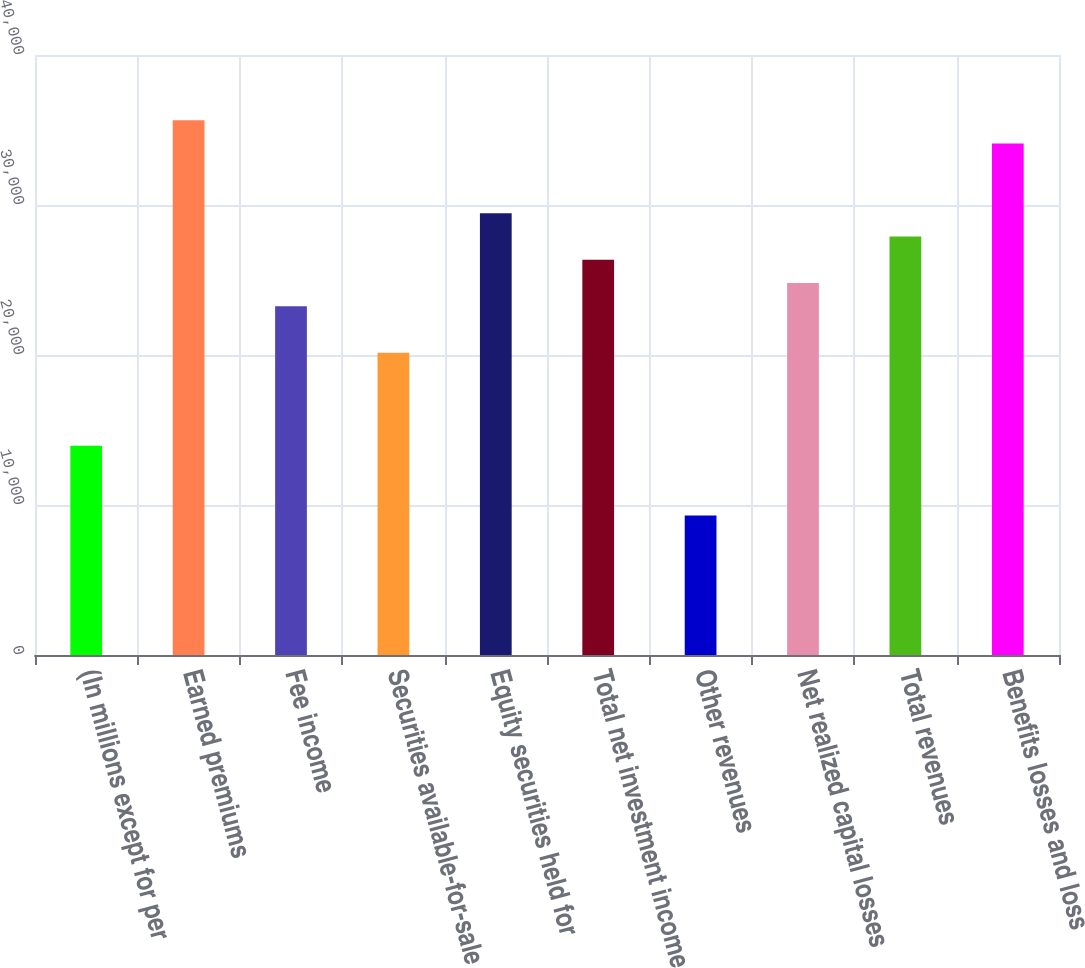Convert chart. <chart><loc_0><loc_0><loc_500><loc_500><bar_chart><fcel>(In millions except for per<fcel>Earned premiums<fcel>Fee income<fcel>Securities available-for-sale<fcel>Equity securities held for<fcel>Total net investment income<fcel>Other revenues<fcel>Net realized capital losses<fcel>Total revenues<fcel>Benefits losses and loss<nl><fcel>13952.9<fcel>35654.4<fcel>23253.6<fcel>20153.3<fcel>29454<fcel>26353.8<fcel>9302.57<fcel>24803.7<fcel>27903.9<fcel>34104.3<nl></chart> 